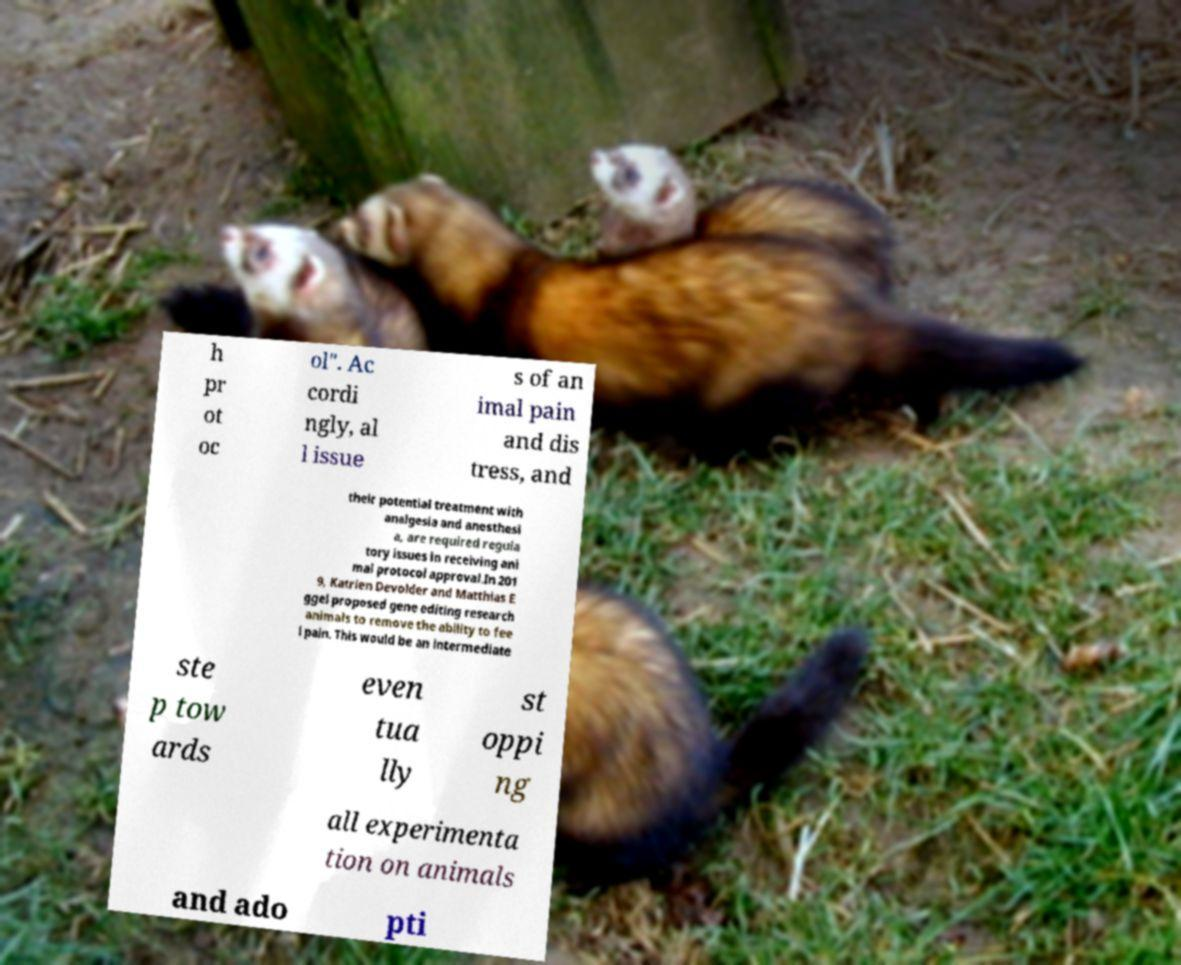Please identify and transcribe the text found in this image. h pr ot oc ol". Ac cordi ngly, al l issue s of an imal pain and dis tress, and their potential treatment with analgesia and anesthesi a, are required regula tory issues in receiving ani mal protocol approval.In 201 9, Katrien Devolder and Matthias E ggel proposed gene editing research animals to remove the ability to fee l pain. This would be an intermediate ste p tow ards even tua lly st oppi ng all experimenta tion on animals and ado pti 